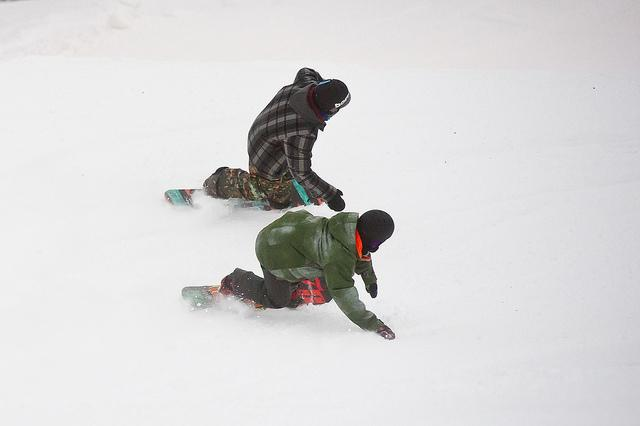What is the person on the right's hand touching?

Choices:
A) cat
B) snow
C) donkey
D) tree snow 